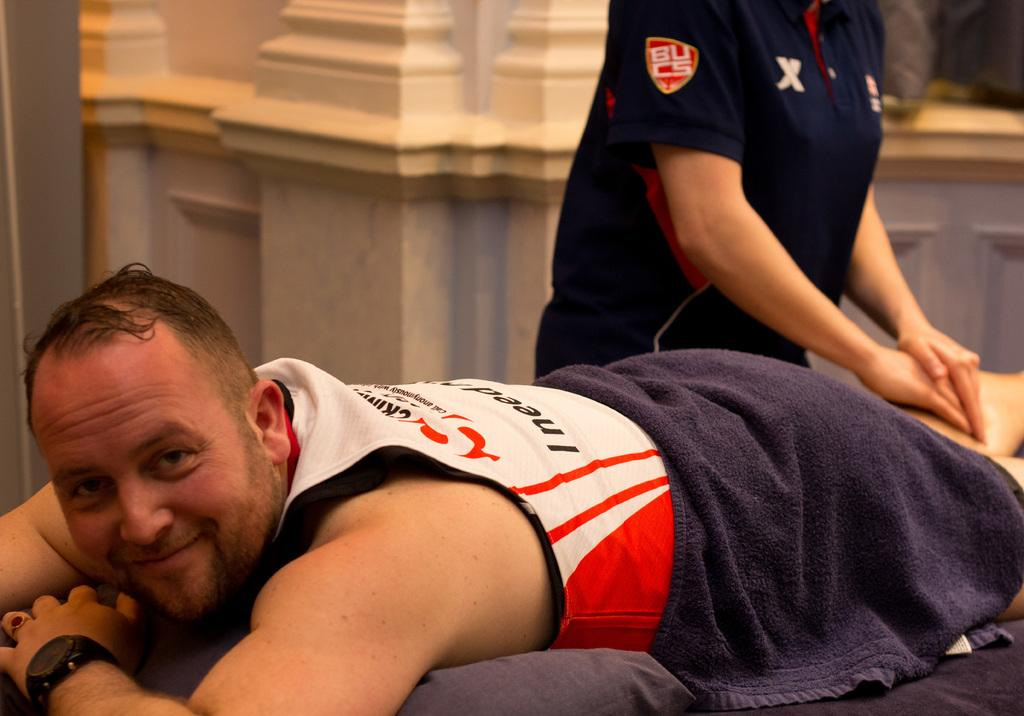Provide a one-sentence caption for the provided image. A person with the letters BUCS on their sleeve massages someone's leg. 